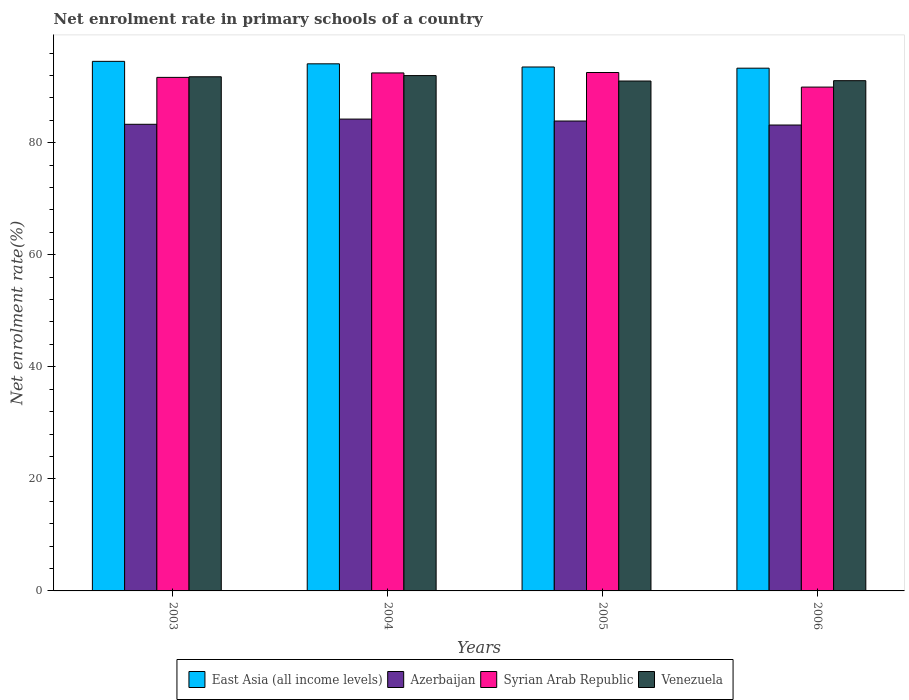How many different coloured bars are there?
Offer a very short reply. 4. How many groups of bars are there?
Your response must be concise. 4. Are the number of bars per tick equal to the number of legend labels?
Provide a succinct answer. Yes. Are the number of bars on each tick of the X-axis equal?
Make the answer very short. Yes. How many bars are there on the 1st tick from the left?
Offer a very short reply. 4. In how many cases, is the number of bars for a given year not equal to the number of legend labels?
Your response must be concise. 0. What is the net enrolment rate in primary schools in Venezuela in 2004?
Offer a terse response. 91.98. Across all years, what is the maximum net enrolment rate in primary schools in Venezuela?
Provide a short and direct response. 91.98. Across all years, what is the minimum net enrolment rate in primary schools in East Asia (all income levels)?
Make the answer very short. 93.3. In which year was the net enrolment rate in primary schools in Azerbaijan maximum?
Offer a very short reply. 2004. In which year was the net enrolment rate in primary schools in Azerbaijan minimum?
Offer a very short reply. 2006. What is the total net enrolment rate in primary schools in Venezuela in the graph?
Offer a very short reply. 365.82. What is the difference between the net enrolment rate in primary schools in East Asia (all income levels) in 2003 and that in 2006?
Your answer should be compact. 1.22. What is the difference between the net enrolment rate in primary schools in Syrian Arab Republic in 2003 and the net enrolment rate in primary schools in Azerbaijan in 2006?
Keep it short and to the point. 8.5. What is the average net enrolment rate in primary schools in Syrian Arab Republic per year?
Offer a very short reply. 91.64. In the year 2005, what is the difference between the net enrolment rate in primary schools in Syrian Arab Republic and net enrolment rate in primary schools in East Asia (all income levels)?
Provide a succinct answer. -0.98. What is the ratio of the net enrolment rate in primary schools in Azerbaijan in 2003 to that in 2006?
Your answer should be compact. 1. What is the difference between the highest and the second highest net enrolment rate in primary schools in East Asia (all income levels)?
Your answer should be compact. 0.44. What is the difference between the highest and the lowest net enrolment rate in primary schools in Syrian Arab Republic?
Your answer should be compact. 2.6. In how many years, is the net enrolment rate in primary schools in Azerbaijan greater than the average net enrolment rate in primary schools in Azerbaijan taken over all years?
Offer a very short reply. 2. Is the sum of the net enrolment rate in primary schools in East Asia (all income levels) in 2004 and 2006 greater than the maximum net enrolment rate in primary schools in Azerbaijan across all years?
Provide a succinct answer. Yes. What does the 2nd bar from the left in 2006 represents?
Your answer should be very brief. Azerbaijan. What does the 1st bar from the right in 2004 represents?
Your response must be concise. Venezuela. Is it the case that in every year, the sum of the net enrolment rate in primary schools in East Asia (all income levels) and net enrolment rate in primary schools in Venezuela is greater than the net enrolment rate in primary schools in Azerbaijan?
Provide a succinct answer. Yes. How many bars are there?
Your response must be concise. 16. Are all the bars in the graph horizontal?
Provide a succinct answer. No. What is the difference between two consecutive major ticks on the Y-axis?
Offer a terse response. 20. Are the values on the major ticks of Y-axis written in scientific E-notation?
Offer a very short reply. No. Does the graph contain any zero values?
Make the answer very short. No. Does the graph contain grids?
Provide a succinct answer. No. How are the legend labels stacked?
Keep it short and to the point. Horizontal. What is the title of the graph?
Ensure brevity in your answer.  Net enrolment rate in primary schools of a country. What is the label or title of the X-axis?
Give a very brief answer. Years. What is the label or title of the Y-axis?
Offer a terse response. Net enrolment rate(%). What is the Net enrolment rate(%) of East Asia (all income levels) in 2003?
Ensure brevity in your answer.  94.52. What is the Net enrolment rate(%) in Azerbaijan in 2003?
Offer a terse response. 83.28. What is the Net enrolment rate(%) of Syrian Arab Republic in 2003?
Provide a succinct answer. 91.66. What is the Net enrolment rate(%) in Venezuela in 2003?
Make the answer very short. 91.77. What is the Net enrolment rate(%) in East Asia (all income levels) in 2004?
Your response must be concise. 94.08. What is the Net enrolment rate(%) of Azerbaijan in 2004?
Make the answer very short. 84.21. What is the Net enrolment rate(%) in Syrian Arab Republic in 2004?
Keep it short and to the point. 92.45. What is the Net enrolment rate(%) of Venezuela in 2004?
Provide a succinct answer. 91.98. What is the Net enrolment rate(%) of East Asia (all income levels) in 2005?
Provide a short and direct response. 93.51. What is the Net enrolment rate(%) of Azerbaijan in 2005?
Ensure brevity in your answer.  83.87. What is the Net enrolment rate(%) in Syrian Arab Republic in 2005?
Ensure brevity in your answer.  92.53. What is the Net enrolment rate(%) in Venezuela in 2005?
Make the answer very short. 91.01. What is the Net enrolment rate(%) in East Asia (all income levels) in 2006?
Give a very brief answer. 93.3. What is the Net enrolment rate(%) of Azerbaijan in 2006?
Provide a succinct answer. 83.15. What is the Net enrolment rate(%) in Syrian Arab Republic in 2006?
Offer a terse response. 89.92. What is the Net enrolment rate(%) of Venezuela in 2006?
Give a very brief answer. 91.07. Across all years, what is the maximum Net enrolment rate(%) of East Asia (all income levels)?
Your answer should be very brief. 94.52. Across all years, what is the maximum Net enrolment rate(%) in Azerbaijan?
Provide a short and direct response. 84.21. Across all years, what is the maximum Net enrolment rate(%) in Syrian Arab Republic?
Make the answer very short. 92.53. Across all years, what is the maximum Net enrolment rate(%) in Venezuela?
Provide a succinct answer. 91.98. Across all years, what is the minimum Net enrolment rate(%) of East Asia (all income levels)?
Make the answer very short. 93.3. Across all years, what is the minimum Net enrolment rate(%) of Azerbaijan?
Ensure brevity in your answer.  83.15. Across all years, what is the minimum Net enrolment rate(%) in Syrian Arab Republic?
Your answer should be very brief. 89.92. Across all years, what is the minimum Net enrolment rate(%) of Venezuela?
Your response must be concise. 91.01. What is the total Net enrolment rate(%) of East Asia (all income levels) in the graph?
Offer a terse response. 375.4. What is the total Net enrolment rate(%) of Azerbaijan in the graph?
Give a very brief answer. 334.52. What is the total Net enrolment rate(%) of Syrian Arab Republic in the graph?
Provide a short and direct response. 366.56. What is the total Net enrolment rate(%) of Venezuela in the graph?
Ensure brevity in your answer.  365.82. What is the difference between the Net enrolment rate(%) of East Asia (all income levels) in 2003 and that in 2004?
Provide a short and direct response. 0.44. What is the difference between the Net enrolment rate(%) of Azerbaijan in 2003 and that in 2004?
Provide a short and direct response. -0.93. What is the difference between the Net enrolment rate(%) in Syrian Arab Republic in 2003 and that in 2004?
Offer a very short reply. -0.79. What is the difference between the Net enrolment rate(%) in Venezuela in 2003 and that in 2004?
Keep it short and to the point. -0.21. What is the difference between the Net enrolment rate(%) of East Asia (all income levels) in 2003 and that in 2005?
Ensure brevity in your answer.  1.01. What is the difference between the Net enrolment rate(%) of Azerbaijan in 2003 and that in 2005?
Provide a succinct answer. -0.58. What is the difference between the Net enrolment rate(%) in Syrian Arab Republic in 2003 and that in 2005?
Ensure brevity in your answer.  -0.87. What is the difference between the Net enrolment rate(%) in Venezuela in 2003 and that in 2005?
Your answer should be very brief. 0.76. What is the difference between the Net enrolment rate(%) in East Asia (all income levels) in 2003 and that in 2006?
Your answer should be compact. 1.22. What is the difference between the Net enrolment rate(%) of Azerbaijan in 2003 and that in 2006?
Provide a succinct answer. 0.13. What is the difference between the Net enrolment rate(%) in Syrian Arab Republic in 2003 and that in 2006?
Your answer should be compact. 1.73. What is the difference between the Net enrolment rate(%) of Venezuela in 2003 and that in 2006?
Provide a short and direct response. 0.7. What is the difference between the Net enrolment rate(%) in East Asia (all income levels) in 2004 and that in 2005?
Keep it short and to the point. 0.57. What is the difference between the Net enrolment rate(%) of Azerbaijan in 2004 and that in 2005?
Keep it short and to the point. 0.34. What is the difference between the Net enrolment rate(%) in Syrian Arab Republic in 2004 and that in 2005?
Keep it short and to the point. -0.07. What is the difference between the Net enrolment rate(%) of Venezuela in 2004 and that in 2005?
Give a very brief answer. 0.97. What is the difference between the Net enrolment rate(%) of East Asia (all income levels) in 2004 and that in 2006?
Ensure brevity in your answer.  0.78. What is the difference between the Net enrolment rate(%) in Azerbaijan in 2004 and that in 2006?
Your answer should be compact. 1.06. What is the difference between the Net enrolment rate(%) in Syrian Arab Republic in 2004 and that in 2006?
Provide a succinct answer. 2.53. What is the difference between the Net enrolment rate(%) in Venezuela in 2004 and that in 2006?
Offer a very short reply. 0.91. What is the difference between the Net enrolment rate(%) in East Asia (all income levels) in 2005 and that in 2006?
Provide a short and direct response. 0.21. What is the difference between the Net enrolment rate(%) in Azerbaijan in 2005 and that in 2006?
Offer a terse response. 0.71. What is the difference between the Net enrolment rate(%) in Syrian Arab Republic in 2005 and that in 2006?
Provide a short and direct response. 2.6. What is the difference between the Net enrolment rate(%) in Venezuela in 2005 and that in 2006?
Offer a very short reply. -0.06. What is the difference between the Net enrolment rate(%) in East Asia (all income levels) in 2003 and the Net enrolment rate(%) in Azerbaijan in 2004?
Give a very brief answer. 10.3. What is the difference between the Net enrolment rate(%) of East Asia (all income levels) in 2003 and the Net enrolment rate(%) of Syrian Arab Republic in 2004?
Ensure brevity in your answer.  2.07. What is the difference between the Net enrolment rate(%) of East Asia (all income levels) in 2003 and the Net enrolment rate(%) of Venezuela in 2004?
Provide a succinct answer. 2.54. What is the difference between the Net enrolment rate(%) in Azerbaijan in 2003 and the Net enrolment rate(%) in Syrian Arab Republic in 2004?
Offer a terse response. -9.17. What is the difference between the Net enrolment rate(%) in Azerbaijan in 2003 and the Net enrolment rate(%) in Venezuela in 2004?
Ensure brevity in your answer.  -8.69. What is the difference between the Net enrolment rate(%) of Syrian Arab Republic in 2003 and the Net enrolment rate(%) of Venezuela in 2004?
Provide a short and direct response. -0.32. What is the difference between the Net enrolment rate(%) in East Asia (all income levels) in 2003 and the Net enrolment rate(%) in Azerbaijan in 2005?
Your answer should be compact. 10.65. What is the difference between the Net enrolment rate(%) of East Asia (all income levels) in 2003 and the Net enrolment rate(%) of Syrian Arab Republic in 2005?
Offer a very short reply. 1.99. What is the difference between the Net enrolment rate(%) of East Asia (all income levels) in 2003 and the Net enrolment rate(%) of Venezuela in 2005?
Your answer should be compact. 3.51. What is the difference between the Net enrolment rate(%) in Azerbaijan in 2003 and the Net enrolment rate(%) in Syrian Arab Republic in 2005?
Ensure brevity in your answer.  -9.24. What is the difference between the Net enrolment rate(%) in Azerbaijan in 2003 and the Net enrolment rate(%) in Venezuela in 2005?
Make the answer very short. -7.72. What is the difference between the Net enrolment rate(%) in Syrian Arab Republic in 2003 and the Net enrolment rate(%) in Venezuela in 2005?
Make the answer very short. 0.65. What is the difference between the Net enrolment rate(%) of East Asia (all income levels) in 2003 and the Net enrolment rate(%) of Azerbaijan in 2006?
Make the answer very short. 11.36. What is the difference between the Net enrolment rate(%) of East Asia (all income levels) in 2003 and the Net enrolment rate(%) of Syrian Arab Republic in 2006?
Ensure brevity in your answer.  4.59. What is the difference between the Net enrolment rate(%) in East Asia (all income levels) in 2003 and the Net enrolment rate(%) in Venezuela in 2006?
Make the answer very short. 3.45. What is the difference between the Net enrolment rate(%) of Azerbaijan in 2003 and the Net enrolment rate(%) of Syrian Arab Republic in 2006?
Your response must be concise. -6.64. What is the difference between the Net enrolment rate(%) in Azerbaijan in 2003 and the Net enrolment rate(%) in Venezuela in 2006?
Your answer should be very brief. -7.78. What is the difference between the Net enrolment rate(%) in Syrian Arab Republic in 2003 and the Net enrolment rate(%) in Venezuela in 2006?
Ensure brevity in your answer.  0.59. What is the difference between the Net enrolment rate(%) in East Asia (all income levels) in 2004 and the Net enrolment rate(%) in Azerbaijan in 2005?
Give a very brief answer. 10.21. What is the difference between the Net enrolment rate(%) of East Asia (all income levels) in 2004 and the Net enrolment rate(%) of Syrian Arab Republic in 2005?
Your response must be concise. 1.55. What is the difference between the Net enrolment rate(%) of East Asia (all income levels) in 2004 and the Net enrolment rate(%) of Venezuela in 2005?
Give a very brief answer. 3.07. What is the difference between the Net enrolment rate(%) of Azerbaijan in 2004 and the Net enrolment rate(%) of Syrian Arab Republic in 2005?
Make the answer very short. -8.31. What is the difference between the Net enrolment rate(%) of Azerbaijan in 2004 and the Net enrolment rate(%) of Venezuela in 2005?
Your answer should be compact. -6.79. What is the difference between the Net enrolment rate(%) in Syrian Arab Republic in 2004 and the Net enrolment rate(%) in Venezuela in 2005?
Ensure brevity in your answer.  1.45. What is the difference between the Net enrolment rate(%) of East Asia (all income levels) in 2004 and the Net enrolment rate(%) of Azerbaijan in 2006?
Keep it short and to the point. 10.92. What is the difference between the Net enrolment rate(%) in East Asia (all income levels) in 2004 and the Net enrolment rate(%) in Syrian Arab Republic in 2006?
Provide a short and direct response. 4.15. What is the difference between the Net enrolment rate(%) in East Asia (all income levels) in 2004 and the Net enrolment rate(%) in Venezuela in 2006?
Give a very brief answer. 3.01. What is the difference between the Net enrolment rate(%) of Azerbaijan in 2004 and the Net enrolment rate(%) of Syrian Arab Republic in 2006?
Your answer should be compact. -5.71. What is the difference between the Net enrolment rate(%) of Azerbaijan in 2004 and the Net enrolment rate(%) of Venezuela in 2006?
Your response must be concise. -6.86. What is the difference between the Net enrolment rate(%) in Syrian Arab Republic in 2004 and the Net enrolment rate(%) in Venezuela in 2006?
Your answer should be compact. 1.38. What is the difference between the Net enrolment rate(%) in East Asia (all income levels) in 2005 and the Net enrolment rate(%) in Azerbaijan in 2006?
Keep it short and to the point. 10.36. What is the difference between the Net enrolment rate(%) in East Asia (all income levels) in 2005 and the Net enrolment rate(%) in Syrian Arab Republic in 2006?
Offer a terse response. 3.59. What is the difference between the Net enrolment rate(%) of East Asia (all income levels) in 2005 and the Net enrolment rate(%) of Venezuela in 2006?
Give a very brief answer. 2.44. What is the difference between the Net enrolment rate(%) of Azerbaijan in 2005 and the Net enrolment rate(%) of Syrian Arab Republic in 2006?
Provide a short and direct response. -6.06. What is the difference between the Net enrolment rate(%) of Azerbaijan in 2005 and the Net enrolment rate(%) of Venezuela in 2006?
Offer a terse response. -7.2. What is the difference between the Net enrolment rate(%) in Syrian Arab Republic in 2005 and the Net enrolment rate(%) in Venezuela in 2006?
Offer a very short reply. 1.46. What is the average Net enrolment rate(%) of East Asia (all income levels) per year?
Your response must be concise. 93.85. What is the average Net enrolment rate(%) of Azerbaijan per year?
Keep it short and to the point. 83.63. What is the average Net enrolment rate(%) of Syrian Arab Republic per year?
Give a very brief answer. 91.64. What is the average Net enrolment rate(%) of Venezuela per year?
Ensure brevity in your answer.  91.45. In the year 2003, what is the difference between the Net enrolment rate(%) of East Asia (all income levels) and Net enrolment rate(%) of Azerbaijan?
Your answer should be compact. 11.23. In the year 2003, what is the difference between the Net enrolment rate(%) of East Asia (all income levels) and Net enrolment rate(%) of Syrian Arab Republic?
Your response must be concise. 2.86. In the year 2003, what is the difference between the Net enrolment rate(%) of East Asia (all income levels) and Net enrolment rate(%) of Venezuela?
Offer a very short reply. 2.75. In the year 2003, what is the difference between the Net enrolment rate(%) of Azerbaijan and Net enrolment rate(%) of Syrian Arab Republic?
Ensure brevity in your answer.  -8.37. In the year 2003, what is the difference between the Net enrolment rate(%) of Azerbaijan and Net enrolment rate(%) of Venezuela?
Your response must be concise. -8.48. In the year 2003, what is the difference between the Net enrolment rate(%) in Syrian Arab Republic and Net enrolment rate(%) in Venezuela?
Provide a succinct answer. -0.11. In the year 2004, what is the difference between the Net enrolment rate(%) in East Asia (all income levels) and Net enrolment rate(%) in Azerbaijan?
Make the answer very short. 9.86. In the year 2004, what is the difference between the Net enrolment rate(%) of East Asia (all income levels) and Net enrolment rate(%) of Syrian Arab Republic?
Offer a very short reply. 1.62. In the year 2004, what is the difference between the Net enrolment rate(%) in East Asia (all income levels) and Net enrolment rate(%) in Venezuela?
Give a very brief answer. 2.1. In the year 2004, what is the difference between the Net enrolment rate(%) of Azerbaijan and Net enrolment rate(%) of Syrian Arab Republic?
Give a very brief answer. -8.24. In the year 2004, what is the difference between the Net enrolment rate(%) of Azerbaijan and Net enrolment rate(%) of Venezuela?
Your answer should be very brief. -7.76. In the year 2004, what is the difference between the Net enrolment rate(%) in Syrian Arab Republic and Net enrolment rate(%) in Venezuela?
Make the answer very short. 0.48. In the year 2005, what is the difference between the Net enrolment rate(%) in East Asia (all income levels) and Net enrolment rate(%) in Azerbaijan?
Your answer should be very brief. 9.64. In the year 2005, what is the difference between the Net enrolment rate(%) of East Asia (all income levels) and Net enrolment rate(%) of Syrian Arab Republic?
Provide a short and direct response. 0.98. In the year 2005, what is the difference between the Net enrolment rate(%) of East Asia (all income levels) and Net enrolment rate(%) of Venezuela?
Your answer should be compact. 2.5. In the year 2005, what is the difference between the Net enrolment rate(%) in Azerbaijan and Net enrolment rate(%) in Syrian Arab Republic?
Give a very brief answer. -8.66. In the year 2005, what is the difference between the Net enrolment rate(%) in Azerbaijan and Net enrolment rate(%) in Venezuela?
Provide a succinct answer. -7.14. In the year 2005, what is the difference between the Net enrolment rate(%) in Syrian Arab Republic and Net enrolment rate(%) in Venezuela?
Give a very brief answer. 1.52. In the year 2006, what is the difference between the Net enrolment rate(%) of East Asia (all income levels) and Net enrolment rate(%) of Azerbaijan?
Ensure brevity in your answer.  10.14. In the year 2006, what is the difference between the Net enrolment rate(%) of East Asia (all income levels) and Net enrolment rate(%) of Syrian Arab Republic?
Offer a very short reply. 3.37. In the year 2006, what is the difference between the Net enrolment rate(%) in East Asia (all income levels) and Net enrolment rate(%) in Venezuela?
Ensure brevity in your answer.  2.23. In the year 2006, what is the difference between the Net enrolment rate(%) of Azerbaijan and Net enrolment rate(%) of Syrian Arab Republic?
Provide a succinct answer. -6.77. In the year 2006, what is the difference between the Net enrolment rate(%) in Azerbaijan and Net enrolment rate(%) in Venezuela?
Your answer should be very brief. -7.92. In the year 2006, what is the difference between the Net enrolment rate(%) of Syrian Arab Republic and Net enrolment rate(%) of Venezuela?
Provide a short and direct response. -1.15. What is the ratio of the Net enrolment rate(%) of East Asia (all income levels) in 2003 to that in 2004?
Give a very brief answer. 1. What is the ratio of the Net enrolment rate(%) of Azerbaijan in 2003 to that in 2004?
Offer a terse response. 0.99. What is the ratio of the Net enrolment rate(%) of Venezuela in 2003 to that in 2004?
Your answer should be very brief. 1. What is the ratio of the Net enrolment rate(%) in East Asia (all income levels) in 2003 to that in 2005?
Your response must be concise. 1.01. What is the ratio of the Net enrolment rate(%) of Azerbaijan in 2003 to that in 2005?
Your answer should be very brief. 0.99. What is the ratio of the Net enrolment rate(%) of Syrian Arab Republic in 2003 to that in 2005?
Give a very brief answer. 0.99. What is the ratio of the Net enrolment rate(%) in Venezuela in 2003 to that in 2005?
Your answer should be compact. 1.01. What is the ratio of the Net enrolment rate(%) of East Asia (all income levels) in 2003 to that in 2006?
Keep it short and to the point. 1.01. What is the ratio of the Net enrolment rate(%) in Syrian Arab Republic in 2003 to that in 2006?
Your answer should be compact. 1.02. What is the ratio of the Net enrolment rate(%) in Venezuela in 2003 to that in 2006?
Your response must be concise. 1.01. What is the ratio of the Net enrolment rate(%) of Syrian Arab Republic in 2004 to that in 2005?
Your answer should be very brief. 1. What is the ratio of the Net enrolment rate(%) of Venezuela in 2004 to that in 2005?
Ensure brevity in your answer.  1.01. What is the ratio of the Net enrolment rate(%) of East Asia (all income levels) in 2004 to that in 2006?
Provide a short and direct response. 1.01. What is the ratio of the Net enrolment rate(%) in Azerbaijan in 2004 to that in 2006?
Your response must be concise. 1.01. What is the ratio of the Net enrolment rate(%) in Syrian Arab Republic in 2004 to that in 2006?
Make the answer very short. 1.03. What is the ratio of the Net enrolment rate(%) of East Asia (all income levels) in 2005 to that in 2006?
Your answer should be very brief. 1. What is the ratio of the Net enrolment rate(%) in Azerbaijan in 2005 to that in 2006?
Offer a terse response. 1.01. What is the ratio of the Net enrolment rate(%) of Syrian Arab Republic in 2005 to that in 2006?
Your answer should be very brief. 1.03. What is the difference between the highest and the second highest Net enrolment rate(%) of East Asia (all income levels)?
Keep it short and to the point. 0.44. What is the difference between the highest and the second highest Net enrolment rate(%) in Azerbaijan?
Keep it short and to the point. 0.34. What is the difference between the highest and the second highest Net enrolment rate(%) of Syrian Arab Republic?
Ensure brevity in your answer.  0.07. What is the difference between the highest and the second highest Net enrolment rate(%) of Venezuela?
Provide a short and direct response. 0.21. What is the difference between the highest and the lowest Net enrolment rate(%) in East Asia (all income levels)?
Ensure brevity in your answer.  1.22. What is the difference between the highest and the lowest Net enrolment rate(%) in Azerbaijan?
Give a very brief answer. 1.06. What is the difference between the highest and the lowest Net enrolment rate(%) of Syrian Arab Republic?
Your answer should be very brief. 2.6. What is the difference between the highest and the lowest Net enrolment rate(%) in Venezuela?
Give a very brief answer. 0.97. 